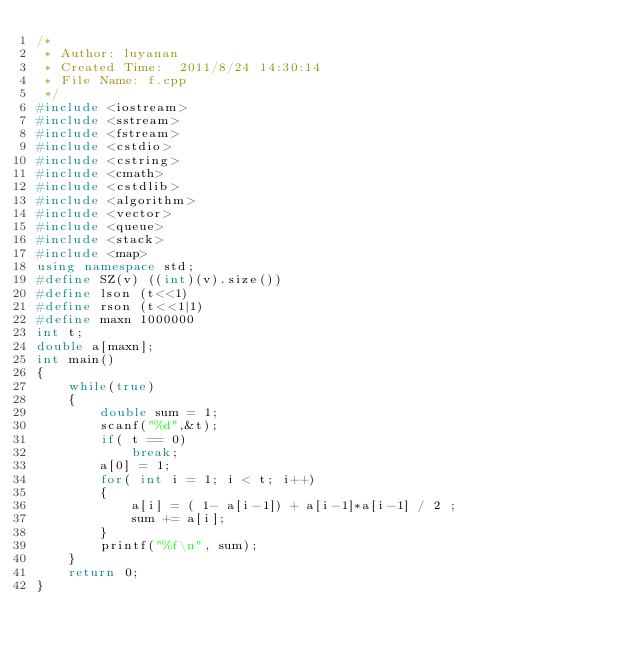<code> <loc_0><loc_0><loc_500><loc_500><_C++_>/*
 * Author: luyanan
 * Created Time:  2011/8/24 14:30:14
 * File Name: f.cpp
 */
#include <iostream>
#include <sstream>
#include <fstream>
#include <cstdio>
#include <cstring>
#include <cmath>
#include <cstdlib>
#include <algorithm>
#include <vector>
#include <queue>
#include <stack>
#include <map>
using namespace std;
#define SZ(v) ((int)(v).size())
#define lson (t<<1)
#define rson (t<<1|1)
#define maxn 1000000
int t;
double a[maxn];
int main() 
{   
    while(true)
    {
        double sum = 1;
        scanf("%d",&t);
        if( t == 0)
            break;
        a[0] = 1;
        for( int i = 1; i < t; i++)
        {
            a[i] = ( 1- a[i-1]) + a[i-1]*a[i-1] / 2 ;
            sum += a[i];
        }
        printf("%f\n", sum);
    }   
    return 0;
}</code> 